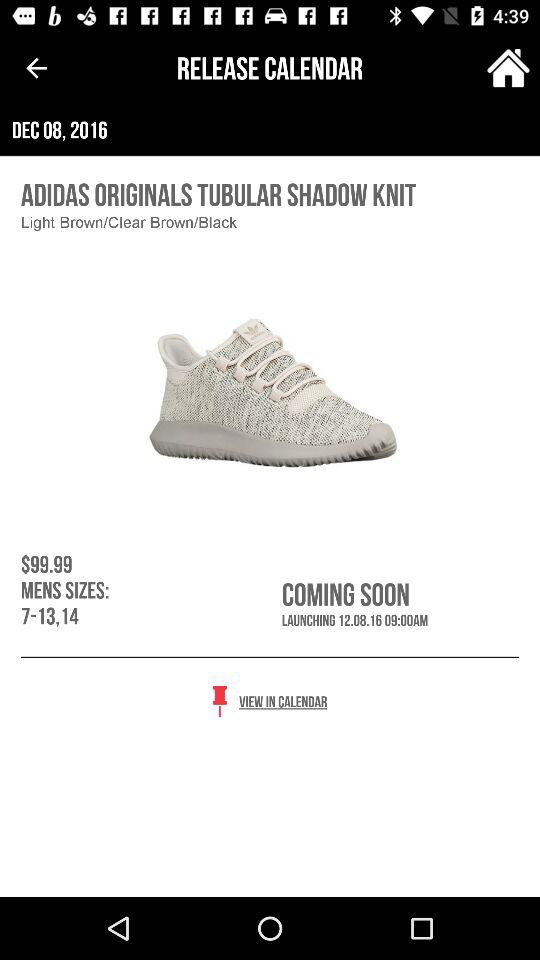Which day of the week falls on 12.08.16?
When the provided information is insufficient, respond with <no answer>. <no answer> 